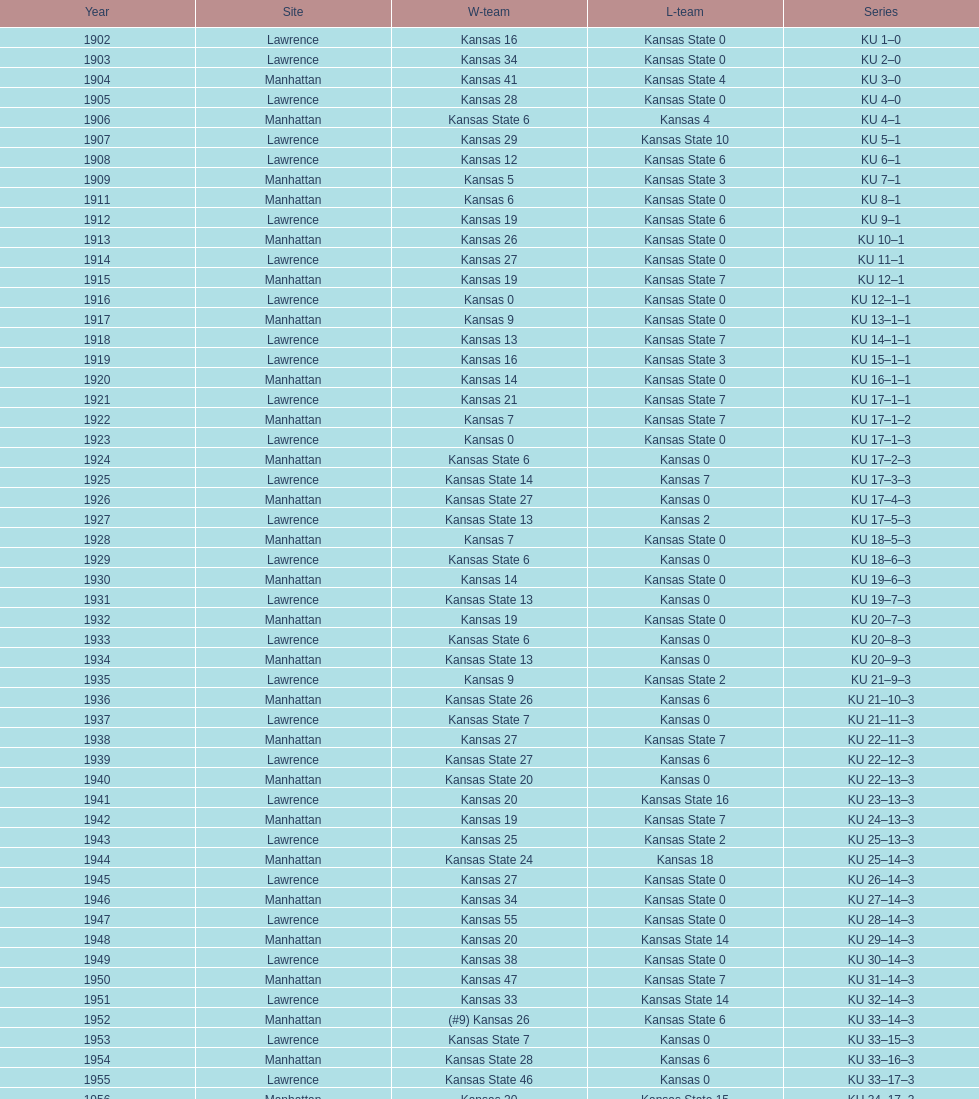What is the total number of games played? 66. 